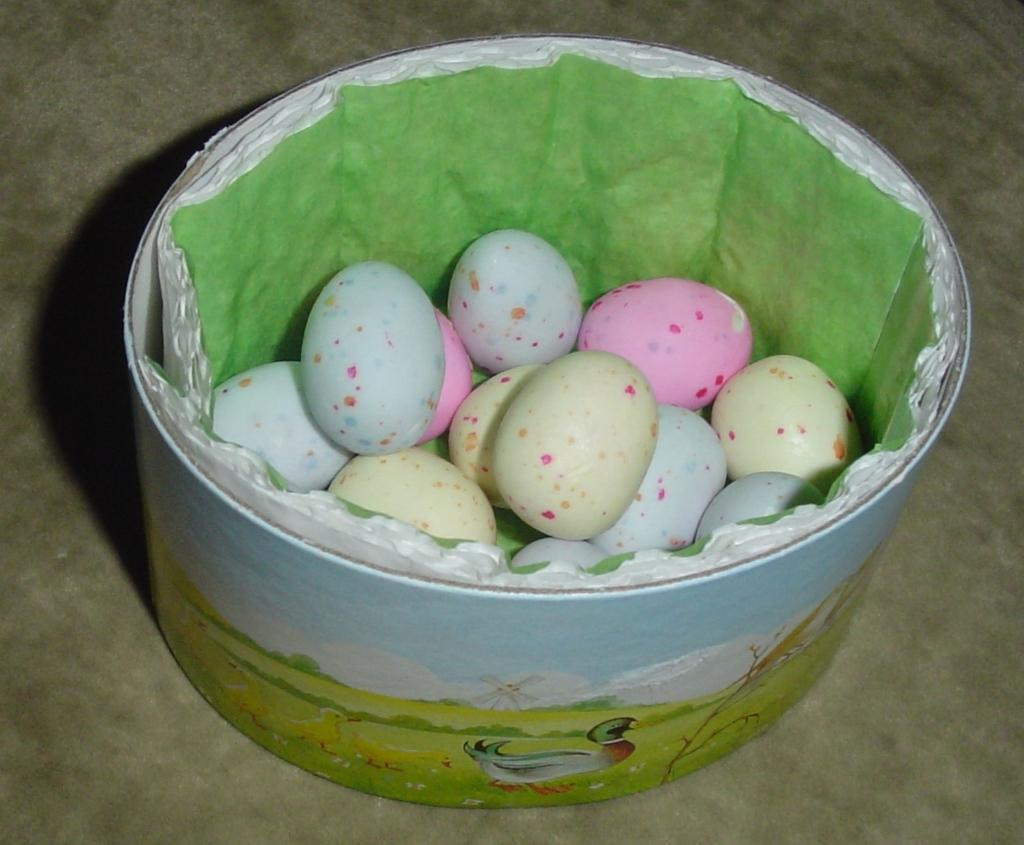What is in the bowl that is visible in the image? There are eggs in a bowl in the image. What can be seen in the background of the image? The background of the image appears to be a floor. What type of worm can be seen crawling on the eggs in the image? There are no worms present in the image; it only shows eggs in a bowl and a floor as the background. 